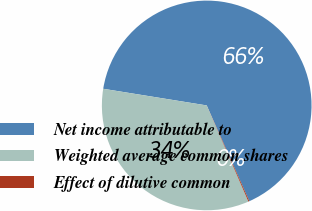Convert chart to OTSL. <chart><loc_0><loc_0><loc_500><loc_500><pie_chart><fcel>Net income attributable to<fcel>Weighted average common shares<fcel>Effect of dilutive common<nl><fcel>65.79%<fcel>34.05%<fcel>0.15%<nl></chart> 